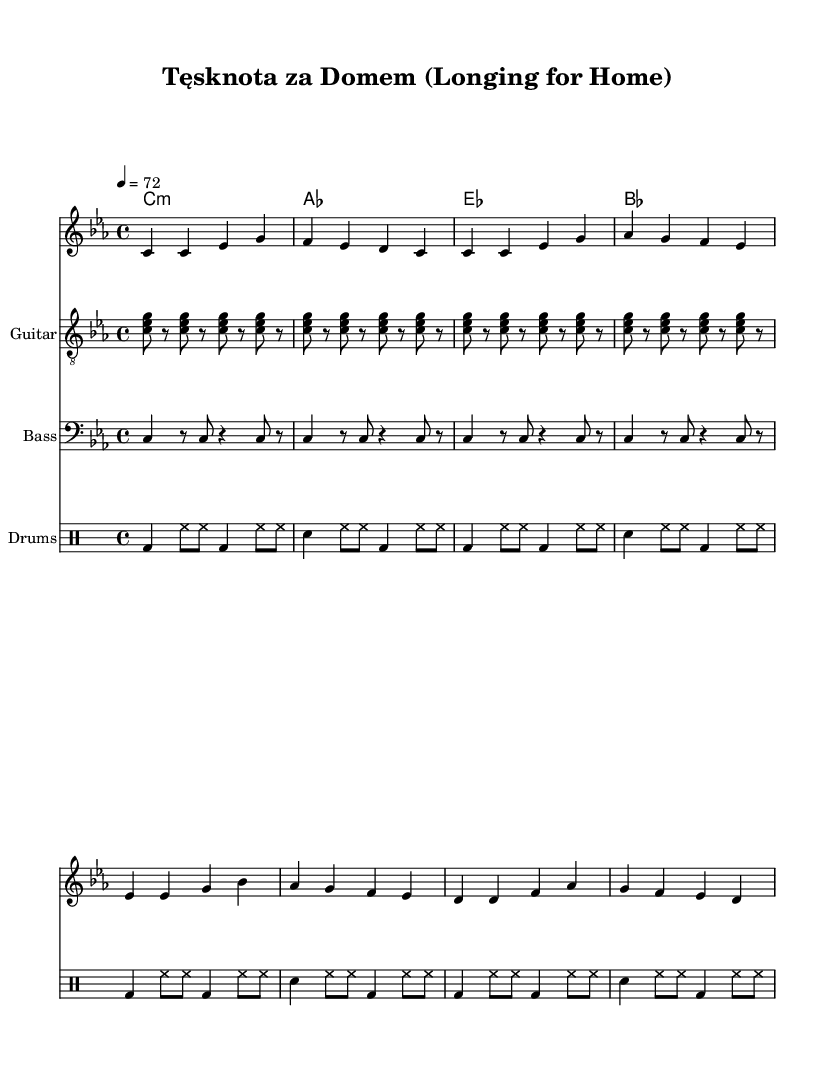What is the key signature of this music? The key signature is C minor, which has three flats (B♭, E♭, A♭). This can be determined from the key indicated at the beginning of the score.
Answer: C minor What is the time signature of this music? The time signature is 4/4, which is shown at the start of the piece, indicating that there are four beats in each measure.
Answer: 4/4 What is the tempo marking for this piece? The tempo marking is 72 beats per minute, indicated by the tempo directive supplied in the score. This specifies how fast the music should be played.
Answer: 72 What instrument is indicated for the guitar part? The score specifies "Guitar" as the instrument name for the guitar part, which is noted next to the staff for the guitar.
Answer: Guitar How many measures are in the melody section of the music? The melody section consists of eight measures, which can be counted visually from the beginning to the end of the melody notation.
Answer: Eight Which aspect of reggae does the lyrics address? The lyrics explore the experiences of Polish immigrants abroad, focusing on themes of longing and resilience typical in conscious reggae songs. This reflects the genre's emphasis on social and personal narratives.
Answer: Experiences of Polish immigrants What type of rhythmic pattern is used in the drums part? The drums part uses a typical reggae rhythmic pattern, which features a kick drum on the downbeat and hi-hat playing on the offbeats. This is a signature rhythmic style of reggae.
Answer: Reggae rhythmic pattern 